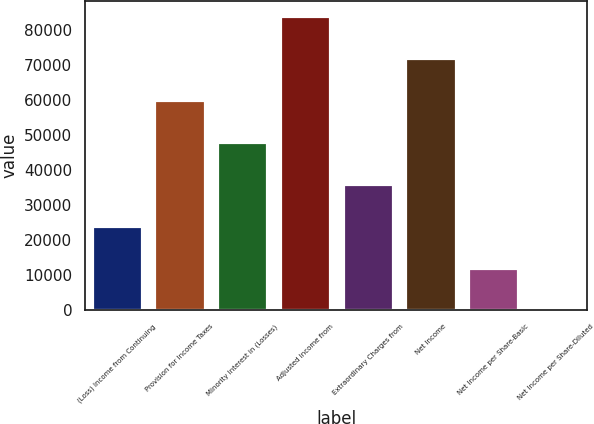Convert chart to OTSL. <chart><loc_0><loc_0><loc_500><loc_500><bar_chart><fcel>(Loss) Income from Continuing<fcel>Provision for Income Taxes<fcel>Minority Interest in (Losses)<fcel>Adjusted Income from<fcel>Extraordinary Charges from<fcel>Net Income<fcel>Net Income per Share-Basic<fcel>Net Income per Share-Diluted<nl><fcel>23990.3<fcel>59974.8<fcel>47980<fcel>83964.5<fcel>35985.2<fcel>71969.7<fcel>11995.5<fcel>0.68<nl></chart> 